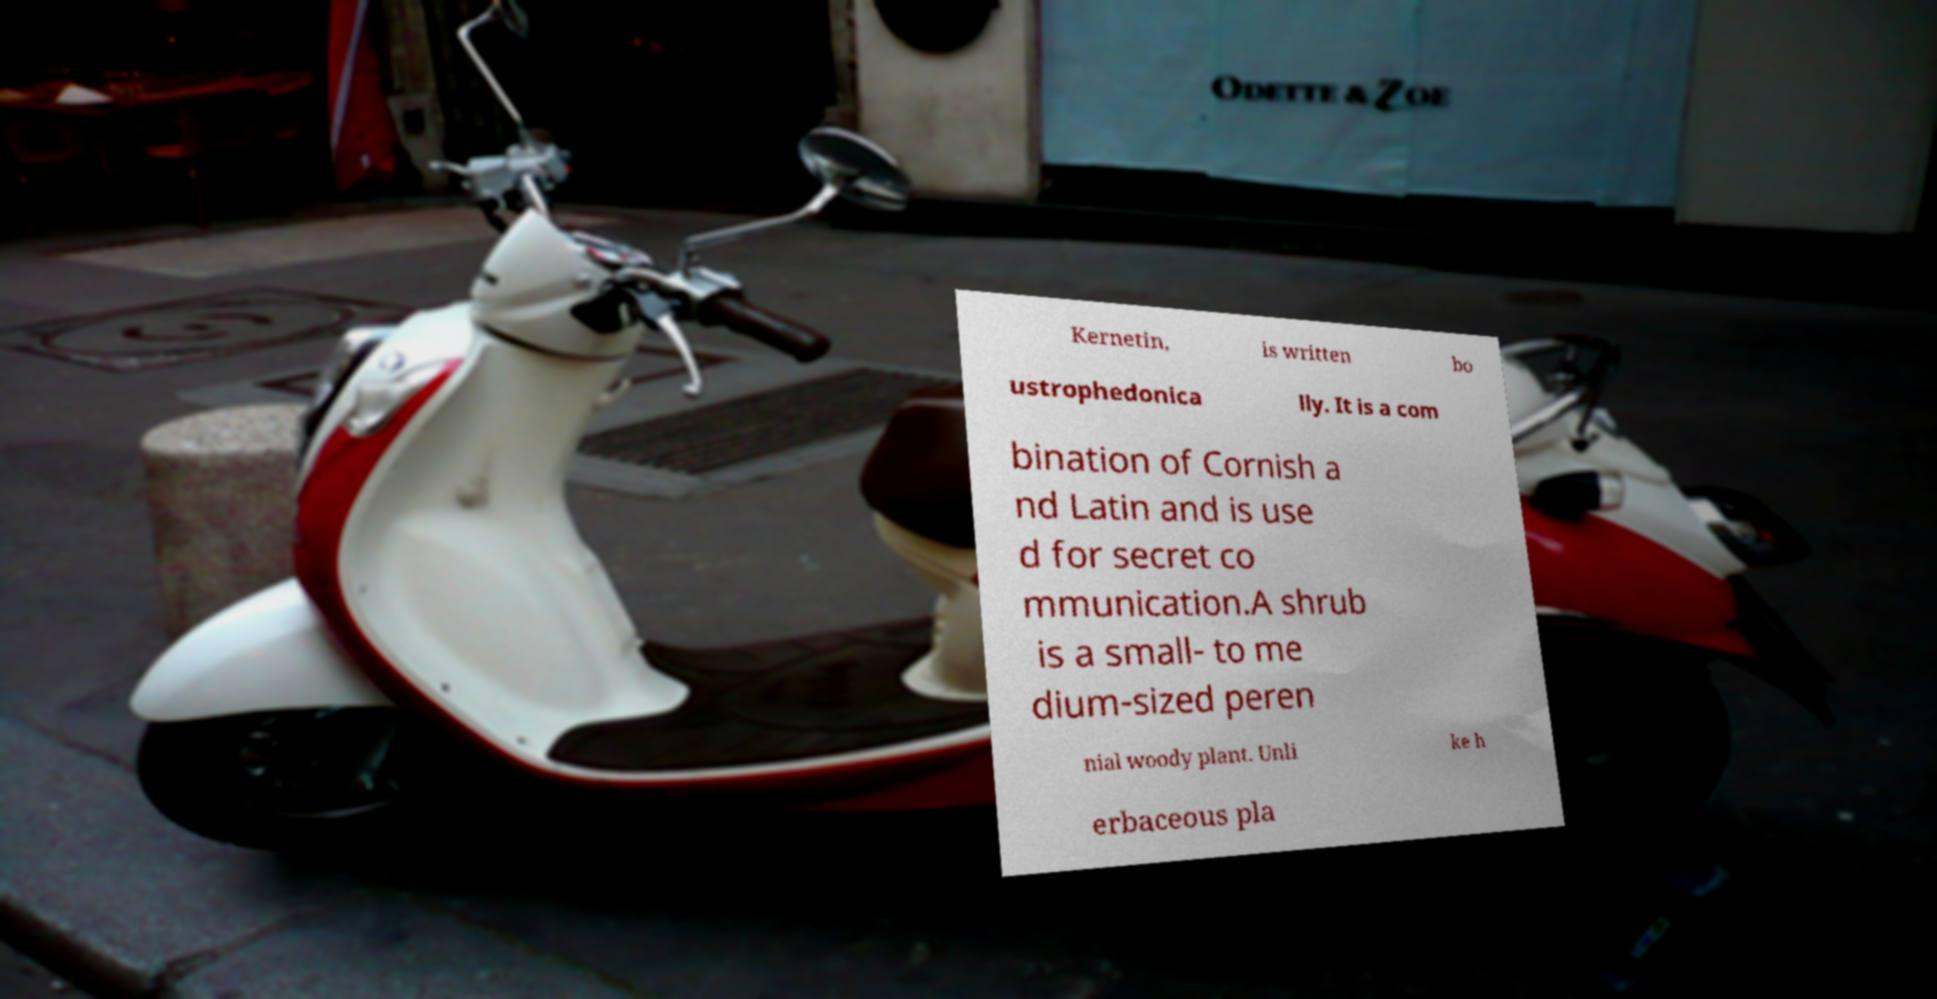Could you extract and type out the text from this image? Kernetin, is written bo ustrophedonica lly. It is a com bination of Cornish a nd Latin and is use d for secret co mmunication.A shrub is a small- to me dium-sized peren nial woody plant. Unli ke h erbaceous pla 